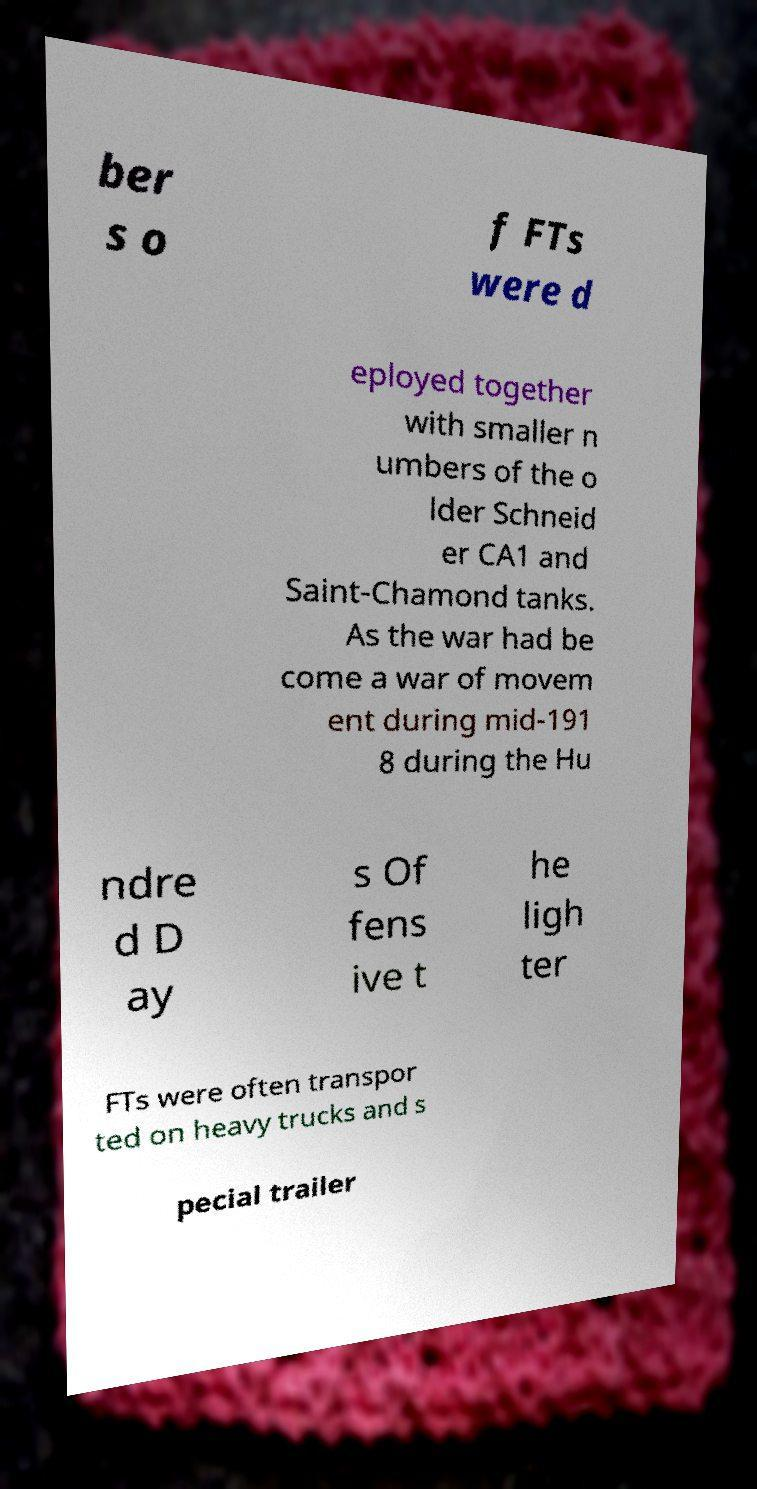Please identify and transcribe the text found in this image. ber s o f FTs were d eployed together with smaller n umbers of the o lder Schneid er CA1 and Saint-Chamond tanks. As the war had be come a war of movem ent during mid-191 8 during the Hu ndre d D ay s Of fens ive t he ligh ter FTs were often transpor ted on heavy trucks and s pecial trailer 